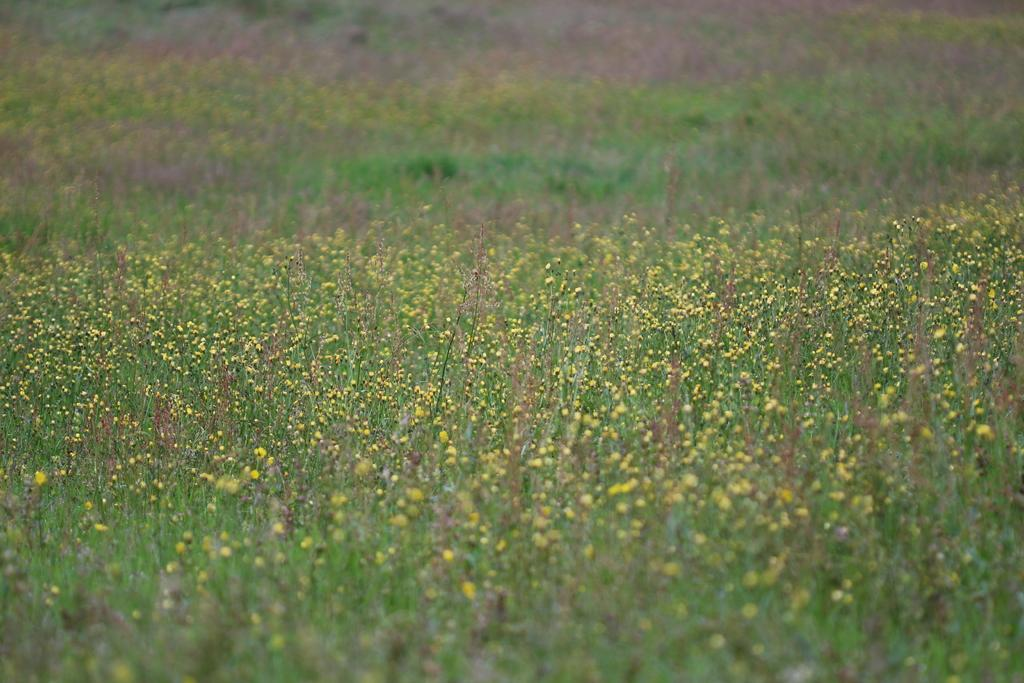What type of plants are visible at the bottom of the image? There are plants with flowers at the bottom of the image. Can you describe the background of the image? The background of the image is blurred. What type of vein can be seen running through the sky in the image? There is no vein visible in the sky, as the sky is not present in the image. 